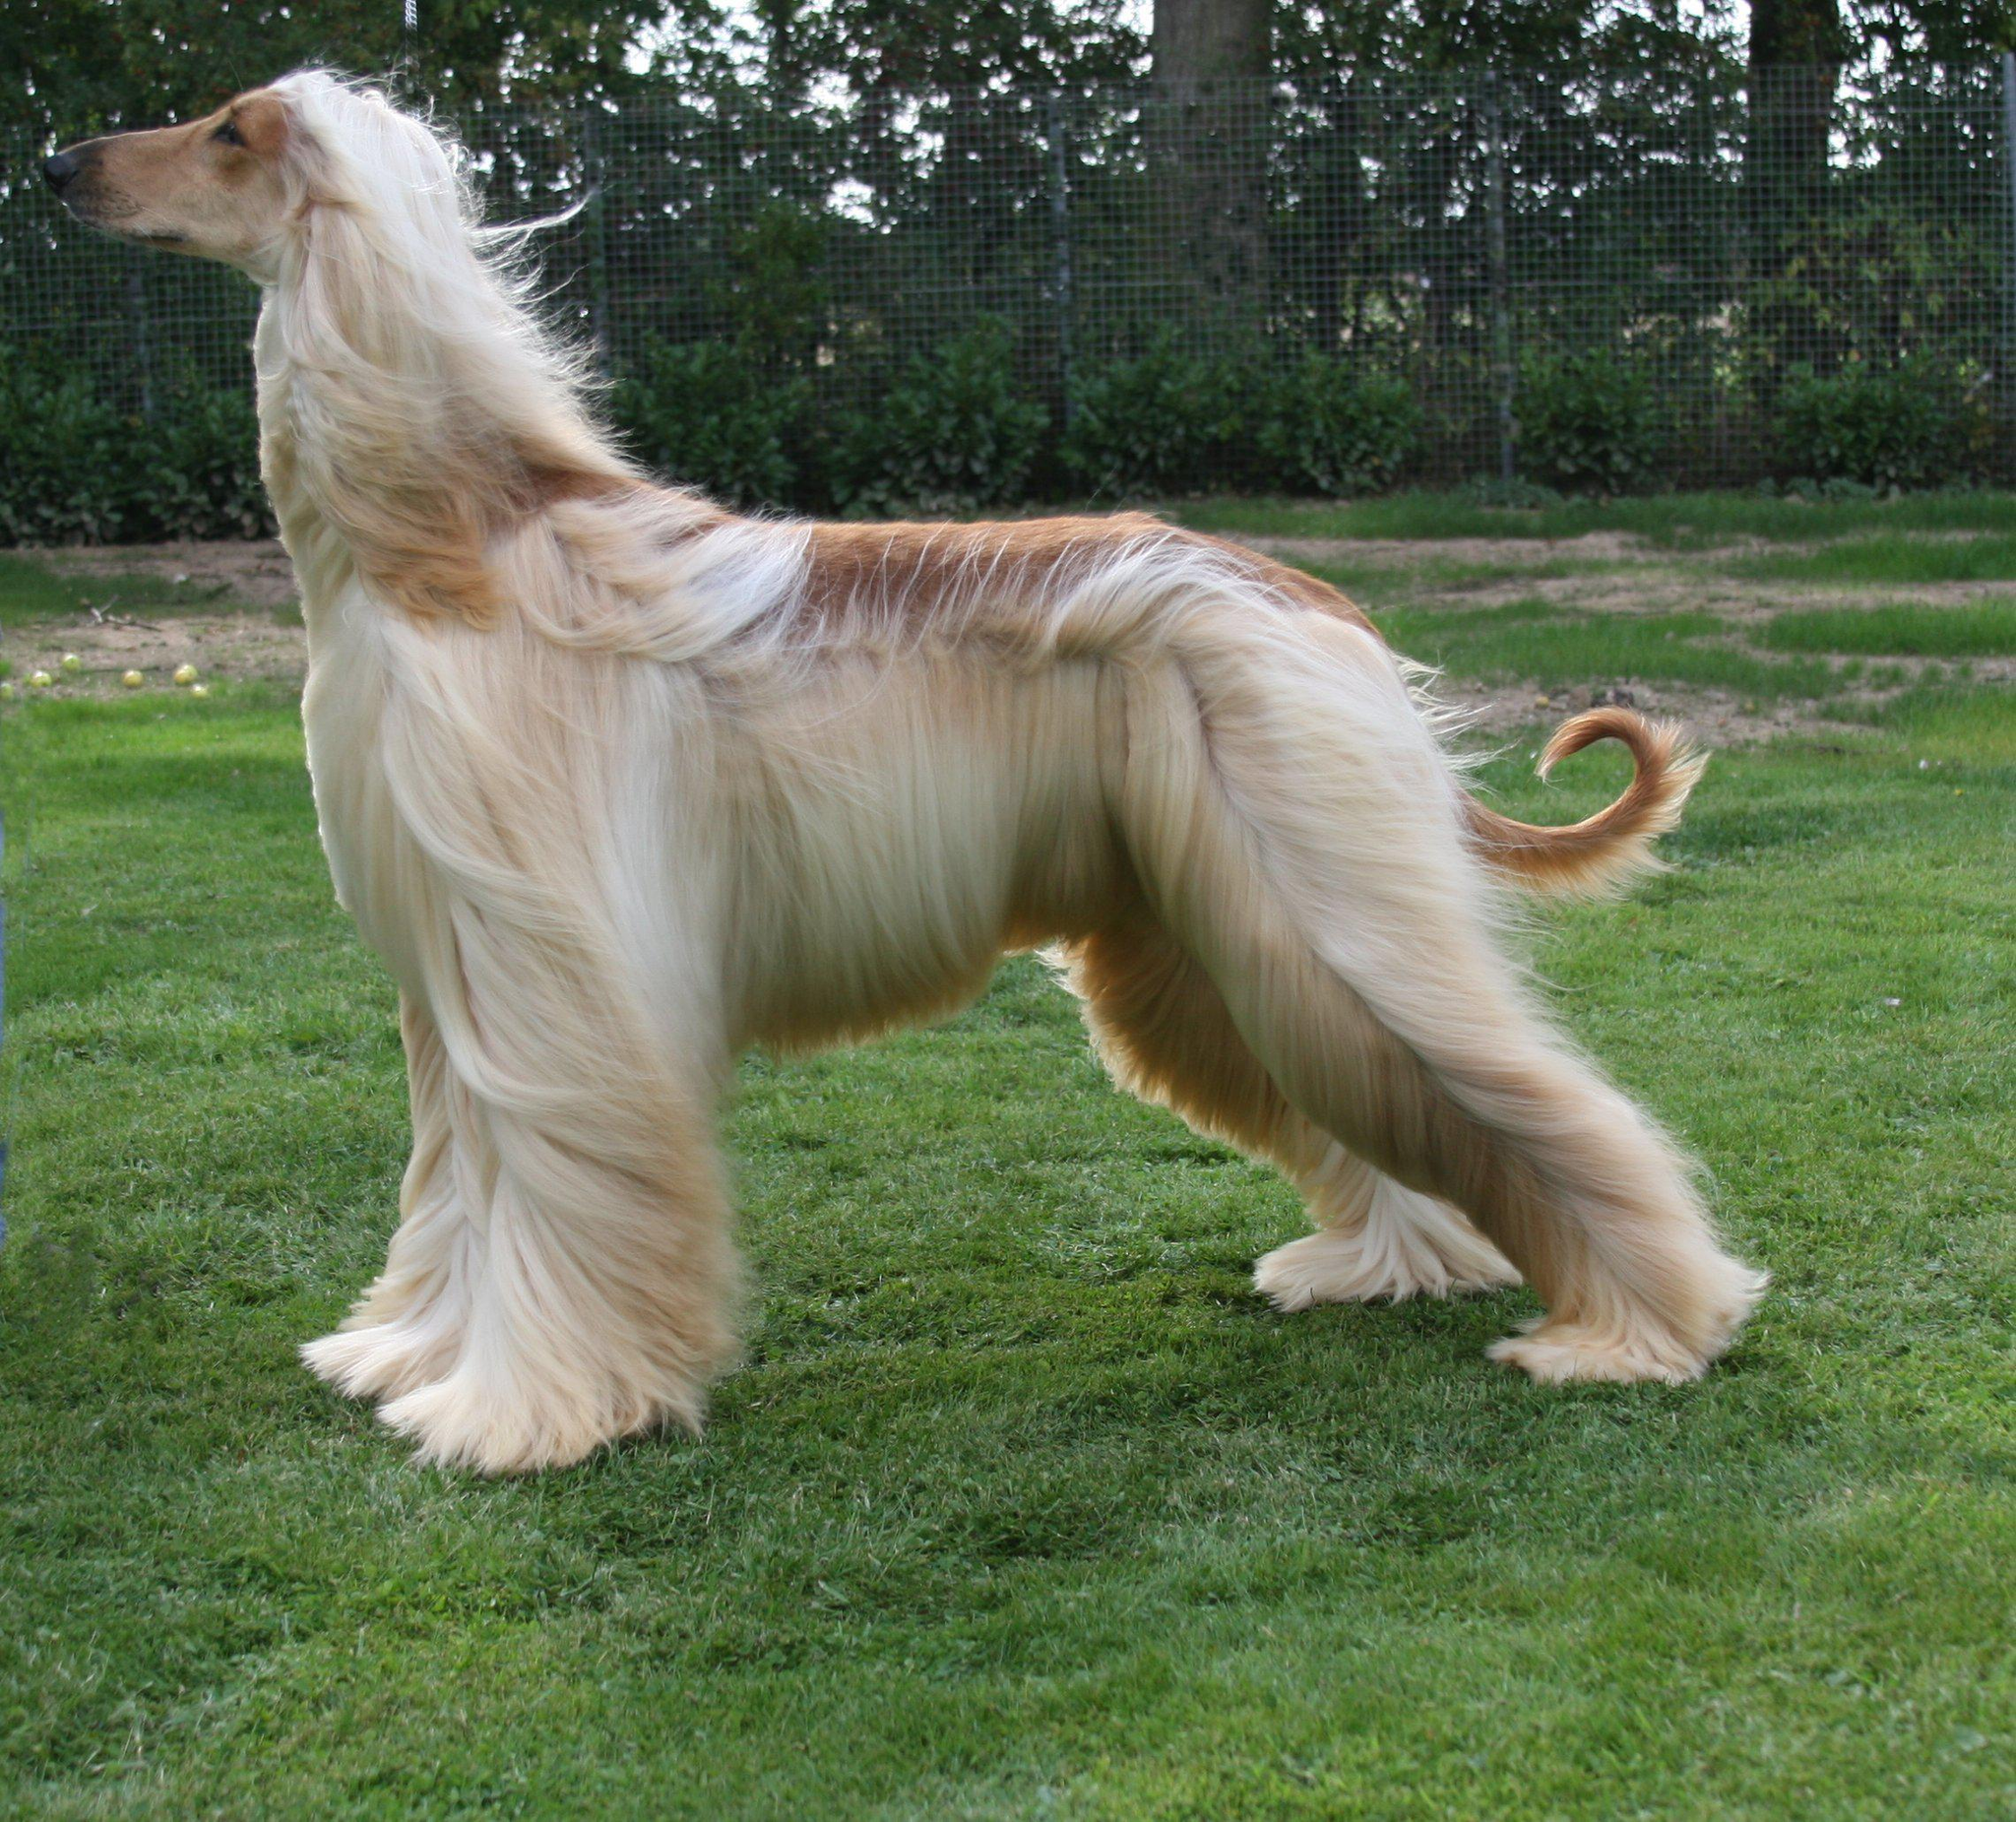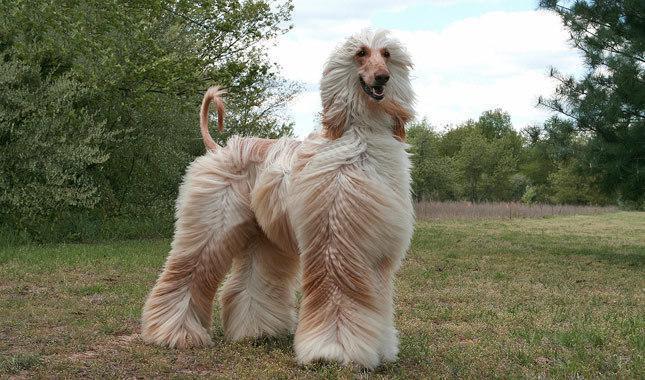The first image is the image on the left, the second image is the image on the right. Assess this claim about the two images: "There is more than one dog in one of the images.". Correct or not? Answer yes or no. No. 